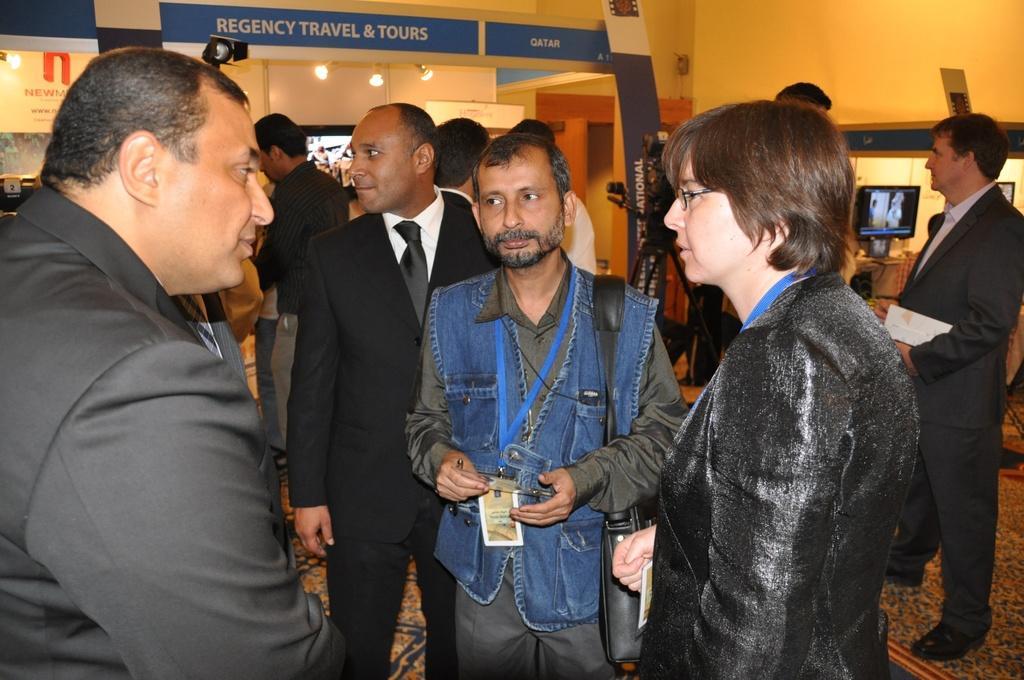Can you describe this image briefly? In this picture, we see many people are standing. The man in the middle of the picture wearing blue coat is wearing a black bag and he is holding a pen in his hand. Behind him, we see a man in white shirt and black blazer is standing and he is smiling. On the right side, we see people are standing. Behind them, we see a monitor is placed on the table. Behind that, we see a wall. In the background, we see a wall. At the top of the picture, we see a thin board in blue color with some text written on it. 